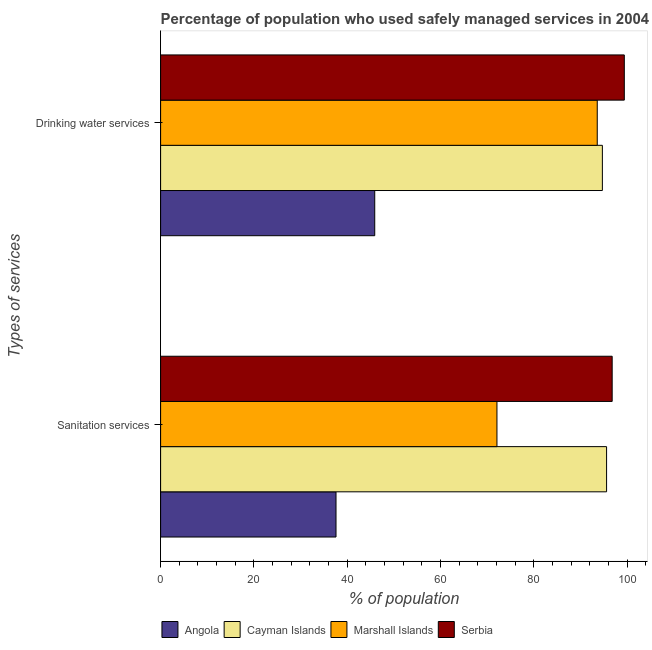How many different coloured bars are there?
Your response must be concise. 4. How many groups of bars are there?
Offer a very short reply. 2. Are the number of bars per tick equal to the number of legend labels?
Ensure brevity in your answer.  Yes. Are the number of bars on each tick of the Y-axis equal?
Provide a short and direct response. Yes. How many bars are there on the 2nd tick from the top?
Offer a terse response. 4. What is the label of the 2nd group of bars from the top?
Offer a very short reply. Sanitation services. What is the percentage of population who used sanitation services in Cayman Islands?
Your answer should be compact. 95.6. Across all countries, what is the maximum percentage of population who used sanitation services?
Offer a terse response. 96.8. Across all countries, what is the minimum percentage of population who used sanitation services?
Your answer should be compact. 37.6. In which country was the percentage of population who used sanitation services maximum?
Keep it short and to the point. Serbia. In which country was the percentage of population who used drinking water services minimum?
Provide a succinct answer. Angola. What is the total percentage of population who used drinking water services in the graph?
Make the answer very short. 333.6. What is the difference between the percentage of population who used drinking water services in Angola and that in Cayman Islands?
Provide a succinct answer. -48.8. What is the difference between the percentage of population who used sanitation services in Serbia and the percentage of population who used drinking water services in Marshall Islands?
Keep it short and to the point. 3.2. What is the average percentage of population who used sanitation services per country?
Provide a succinct answer. 75.52. What is the difference between the percentage of population who used drinking water services and percentage of population who used sanitation services in Angola?
Your response must be concise. 8.3. In how many countries, is the percentage of population who used sanitation services greater than 16 %?
Offer a very short reply. 4. What is the ratio of the percentage of population who used sanitation services in Marshall Islands to that in Cayman Islands?
Make the answer very short. 0.75. In how many countries, is the percentage of population who used drinking water services greater than the average percentage of population who used drinking water services taken over all countries?
Make the answer very short. 3. What does the 4th bar from the top in Sanitation services represents?
Give a very brief answer. Angola. What does the 4th bar from the bottom in Sanitation services represents?
Your answer should be very brief. Serbia. How many bars are there?
Your response must be concise. 8. Are all the bars in the graph horizontal?
Ensure brevity in your answer.  Yes. What is the difference between two consecutive major ticks on the X-axis?
Make the answer very short. 20. Are the values on the major ticks of X-axis written in scientific E-notation?
Ensure brevity in your answer.  No. Does the graph contain any zero values?
Make the answer very short. No. Does the graph contain grids?
Give a very brief answer. No. Where does the legend appear in the graph?
Provide a short and direct response. Bottom center. What is the title of the graph?
Offer a very short reply. Percentage of population who used safely managed services in 2004. What is the label or title of the X-axis?
Make the answer very short. % of population. What is the label or title of the Y-axis?
Keep it short and to the point. Types of services. What is the % of population in Angola in Sanitation services?
Provide a succinct answer. 37.6. What is the % of population in Cayman Islands in Sanitation services?
Offer a very short reply. 95.6. What is the % of population of Marshall Islands in Sanitation services?
Provide a succinct answer. 72.1. What is the % of population in Serbia in Sanitation services?
Make the answer very short. 96.8. What is the % of population in Angola in Drinking water services?
Your response must be concise. 45.9. What is the % of population in Cayman Islands in Drinking water services?
Provide a succinct answer. 94.7. What is the % of population in Marshall Islands in Drinking water services?
Keep it short and to the point. 93.6. What is the % of population in Serbia in Drinking water services?
Provide a succinct answer. 99.4. Across all Types of services, what is the maximum % of population of Angola?
Provide a short and direct response. 45.9. Across all Types of services, what is the maximum % of population in Cayman Islands?
Provide a short and direct response. 95.6. Across all Types of services, what is the maximum % of population in Marshall Islands?
Provide a succinct answer. 93.6. Across all Types of services, what is the maximum % of population of Serbia?
Make the answer very short. 99.4. Across all Types of services, what is the minimum % of population of Angola?
Make the answer very short. 37.6. Across all Types of services, what is the minimum % of population of Cayman Islands?
Provide a succinct answer. 94.7. Across all Types of services, what is the minimum % of population of Marshall Islands?
Provide a succinct answer. 72.1. Across all Types of services, what is the minimum % of population in Serbia?
Provide a succinct answer. 96.8. What is the total % of population in Angola in the graph?
Your answer should be compact. 83.5. What is the total % of population of Cayman Islands in the graph?
Your answer should be very brief. 190.3. What is the total % of population in Marshall Islands in the graph?
Keep it short and to the point. 165.7. What is the total % of population of Serbia in the graph?
Provide a short and direct response. 196.2. What is the difference between the % of population of Angola in Sanitation services and that in Drinking water services?
Your response must be concise. -8.3. What is the difference between the % of population of Cayman Islands in Sanitation services and that in Drinking water services?
Offer a terse response. 0.9. What is the difference between the % of population of Marshall Islands in Sanitation services and that in Drinking water services?
Give a very brief answer. -21.5. What is the difference between the % of population of Serbia in Sanitation services and that in Drinking water services?
Offer a terse response. -2.6. What is the difference between the % of population of Angola in Sanitation services and the % of population of Cayman Islands in Drinking water services?
Your answer should be compact. -57.1. What is the difference between the % of population in Angola in Sanitation services and the % of population in Marshall Islands in Drinking water services?
Ensure brevity in your answer.  -56. What is the difference between the % of population in Angola in Sanitation services and the % of population in Serbia in Drinking water services?
Your response must be concise. -61.8. What is the difference between the % of population of Cayman Islands in Sanitation services and the % of population of Marshall Islands in Drinking water services?
Your answer should be very brief. 2. What is the difference between the % of population of Cayman Islands in Sanitation services and the % of population of Serbia in Drinking water services?
Offer a terse response. -3.8. What is the difference between the % of population of Marshall Islands in Sanitation services and the % of population of Serbia in Drinking water services?
Provide a short and direct response. -27.3. What is the average % of population of Angola per Types of services?
Offer a very short reply. 41.75. What is the average % of population of Cayman Islands per Types of services?
Provide a short and direct response. 95.15. What is the average % of population in Marshall Islands per Types of services?
Provide a succinct answer. 82.85. What is the average % of population in Serbia per Types of services?
Your answer should be very brief. 98.1. What is the difference between the % of population of Angola and % of population of Cayman Islands in Sanitation services?
Make the answer very short. -58. What is the difference between the % of population in Angola and % of population in Marshall Islands in Sanitation services?
Ensure brevity in your answer.  -34.5. What is the difference between the % of population in Angola and % of population in Serbia in Sanitation services?
Your answer should be compact. -59.2. What is the difference between the % of population in Cayman Islands and % of population in Marshall Islands in Sanitation services?
Your answer should be very brief. 23.5. What is the difference between the % of population of Marshall Islands and % of population of Serbia in Sanitation services?
Offer a very short reply. -24.7. What is the difference between the % of population of Angola and % of population of Cayman Islands in Drinking water services?
Make the answer very short. -48.8. What is the difference between the % of population in Angola and % of population in Marshall Islands in Drinking water services?
Offer a very short reply. -47.7. What is the difference between the % of population of Angola and % of population of Serbia in Drinking water services?
Your answer should be very brief. -53.5. What is the difference between the % of population in Cayman Islands and % of population in Serbia in Drinking water services?
Offer a terse response. -4.7. What is the ratio of the % of population of Angola in Sanitation services to that in Drinking water services?
Make the answer very short. 0.82. What is the ratio of the % of population of Cayman Islands in Sanitation services to that in Drinking water services?
Your response must be concise. 1.01. What is the ratio of the % of population in Marshall Islands in Sanitation services to that in Drinking water services?
Your answer should be very brief. 0.77. What is the ratio of the % of population in Serbia in Sanitation services to that in Drinking water services?
Make the answer very short. 0.97. What is the difference between the highest and the second highest % of population of Serbia?
Ensure brevity in your answer.  2.6. What is the difference between the highest and the lowest % of population in Serbia?
Offer a terse response. 2.6. 